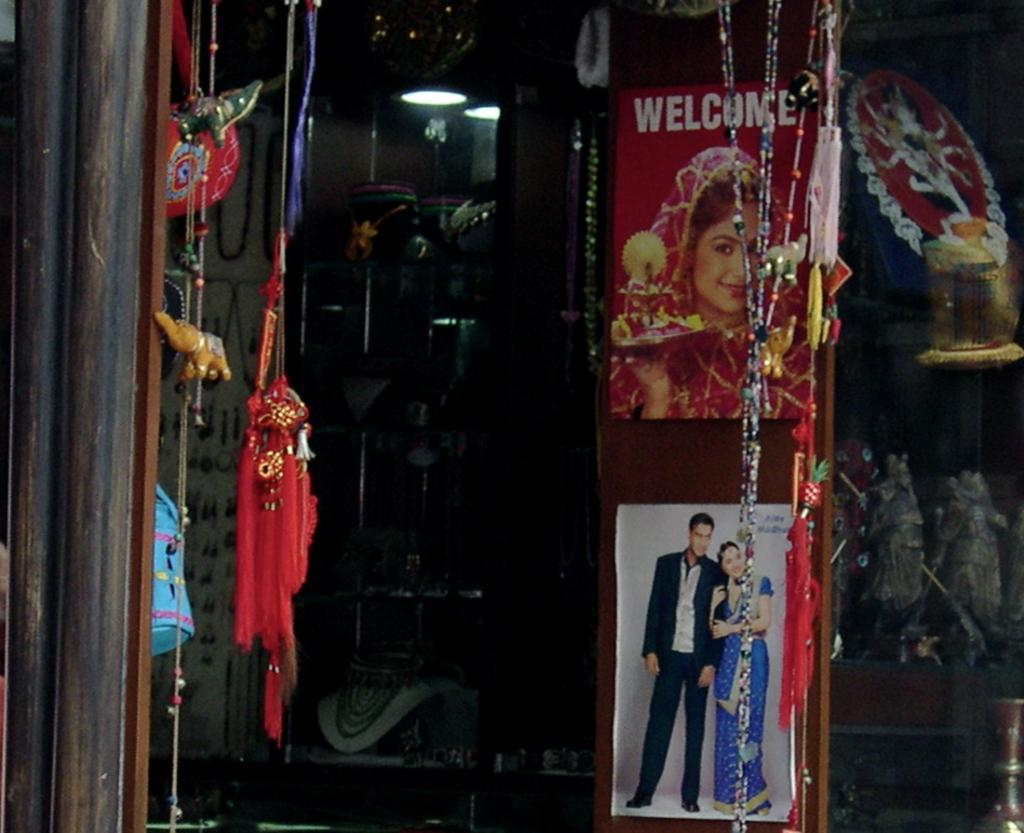What type of establishment is depicted in the image? There is a store in the image. What can be found inside the store? Sculptures are placed in a rack inside the store. What is on the wooden door in the store? Posters are stuck to a wooden door in the store. Who created the holiday-themed riddle on the sculpture in the image? There is no holiday-themed riddle or creator mentioned in the image; it only shows a store with sculptures in a rack and posters on a wooden door. 